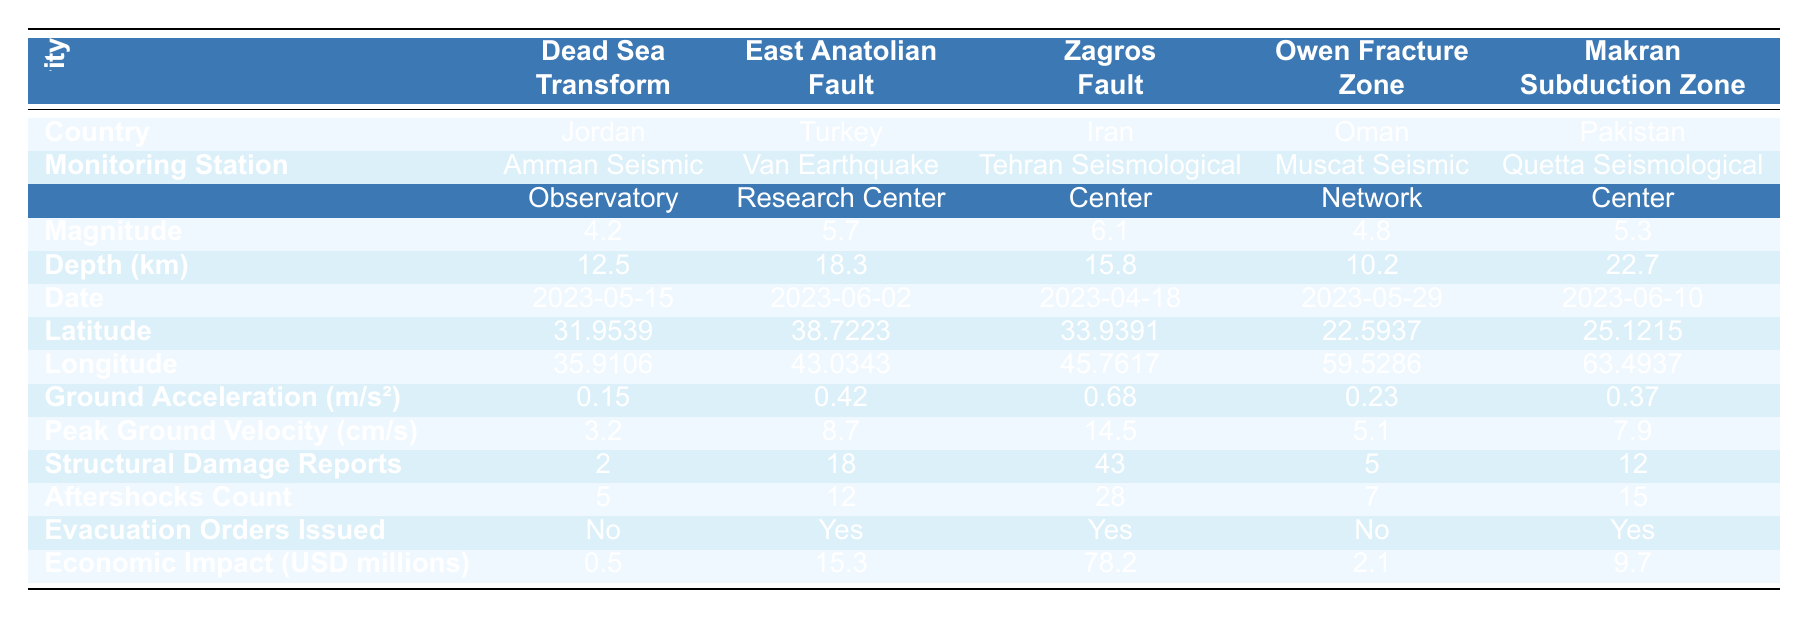What is the maximum magnitude recorded among the fault lines? The maximum magnitude can be found by comparing the magnitude values in the table. The values are 4.2, 5.7, 6.1, 4.8, and 5.3. The highest value is 6.1.
Answer: 6.1 Which country has the highest number of structural damage reports? The structural damage reports for each country are 2, 18, 43, 5, and 12. The maximum value is 43, which corresponds to Iran.
Answer: Iran How deep is the East Anatolian Fault, and how does it compare to the Makran Subduction Zone? The depth of the East Anatolian Fault is 18.3 km, while the depth of the Makran Subduction Zone is 22.7 km. When comparing the two, the Makran Subduction Zone is deeper by 22.7 - 18.3 = 4.4 km.
Answer: 18.3 km, Makran is deeper by 4.4 km How many evacuation orders were issued across all fault lines? The evacuation orders issued are true for East Anatolian Fault (Turkey), Zagros Fault (Iran), and Makran Subduction Zone (Pakistan). Adding them gives a total of 3 evacuation orders.
Answer: 3 What was the average economic impact of the seismic activity across the fault lines? The economic impact values are 0.5, 15.3, 78.2, 2.1, and 9.7. Summing them gives 0.5 + 15.3 + 78.2 + 2.1 + 9.7 = 105.8. Dividing by the number of fault lines (5) results in an average economic impact of 105.8 / 5 = 21.16 million USD.
Answer: 21.16 million USD What is the difference in the peak ground velocity between the Zagros Fault and the Owen Fracture Zone? The peak ground velocities are 14.5 cm/s for the Zagros Fault and 5.1 cm/s for the Owen Fracture Zone. The difference is 14.5 - 5.1 = 9.4 cm/s.
Answer: 9.4 cm/s Which fault line had the least ground acceleration and what was the value? The ground acceleration values are 0.15, 0.42, 0.68, 0.23, and 0.37. The least value is 0.15, which is associated with the Dead Sea Transform.
Answer: Dead Sea Transform, 0.15 m/s² How many aftershocks occurred for the Zagros Fault, and how does that compare to the Dead Sea Transform? The Zagros Fault had 28 aftershocks, while the Dead Sea Transform had 5 aftershocks. Comparing them shows that Zagros Fault had 28 - 5 = 23 more aftershocks than the Dead Sea Transform.
Answer: Zagros had 28, 23 more than Dead Sea Which country reported the highest economic impact and what was the amount? The economic impacts for each country are 0.5 million USD (Jordan), 15.3 million USD (Turkey), 78.2 million USD (Iran), 2.1 million USD (Oman), and 9.7 million USD (Pakistan). The highest impact is 78.2 million USD, which belongs to Iran.
Answer: Iran, 78.2 million USD Were any evacuation orders issued for the Dead Sea Transform? According to the table, no evacuation orders were issued for the Dead Sea Transform since it is listed as "No."
Answer: No 